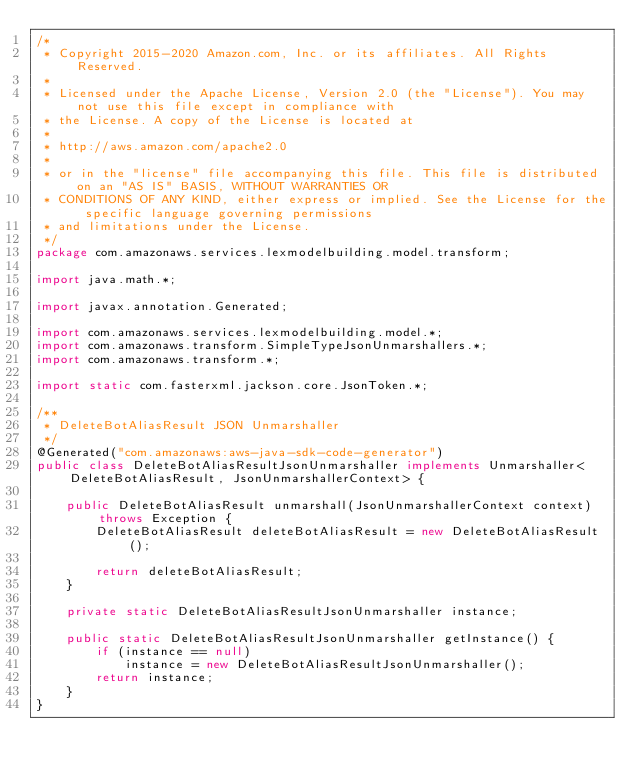<code> <loc_0><loc_0><loc_500><loc_500><_Java_>/*
 * Copyright 2015-2020 Amazon.com, Inc. or its affiliates. All Rights Reserved.
 * 
 * Licensed under the Apache License, Version 2.0 (the "License"). You may not use this file except in compliance with
 * the License. A copy of the License is located at
 * 
 * http://aws.amazon.com/apache2.0
 * 
 * or in the "license" file accompanying this file. This file is distributed on an "AS IS" BASIS, WITHOUT WARRANTIES OR
 * CONDITIONS OF ANY KIND, either express or implied. See the License for the specific language governing permissions
 * and limitations under the License.
 */
package com.amazonaws.services.lexmodelbuilding.model.transform;

import java.math.*;

import javax.annotation.Generated;

import com.amazonaws.services.lexmodelbuilding.model.*;
import com.amazonaws.transform.SimpleTypeJsonUnmarshallers.*;
import com.amazonaws.transform.*;

import static com.fasterxml.jackson.core.JsonToken.*;

/**
 * DeleteBotAliasResult JSON Unmarshaller
 */
@Generated("com.amazonaws:aws-java-sdk-code-generator")
public class DeleteBotAliasResultJsonUnmarshaller implements Unmarshaller<DeleteBotAliasResult, JsonUnmarshallerContext> {

    public DeleteBotAliasResult unmarshall(JsonUnmarshallerContext context) throws Exception {
        DeleteBotAliasResult deleteBotAliasResult = new DeleteBotAliasResult();

        return deleteBotAliasResult;
    }

    private static DeleteBotAliasResultJsonUnmarshaller instance;

    public static DeleteBotAliasResultJsonUnmarshaller getInstance() {
        if (instance == null)
            instance = new DeleteBotAliasResultJsonUnmarshaller();
        return instance;
    }
}
</code> 